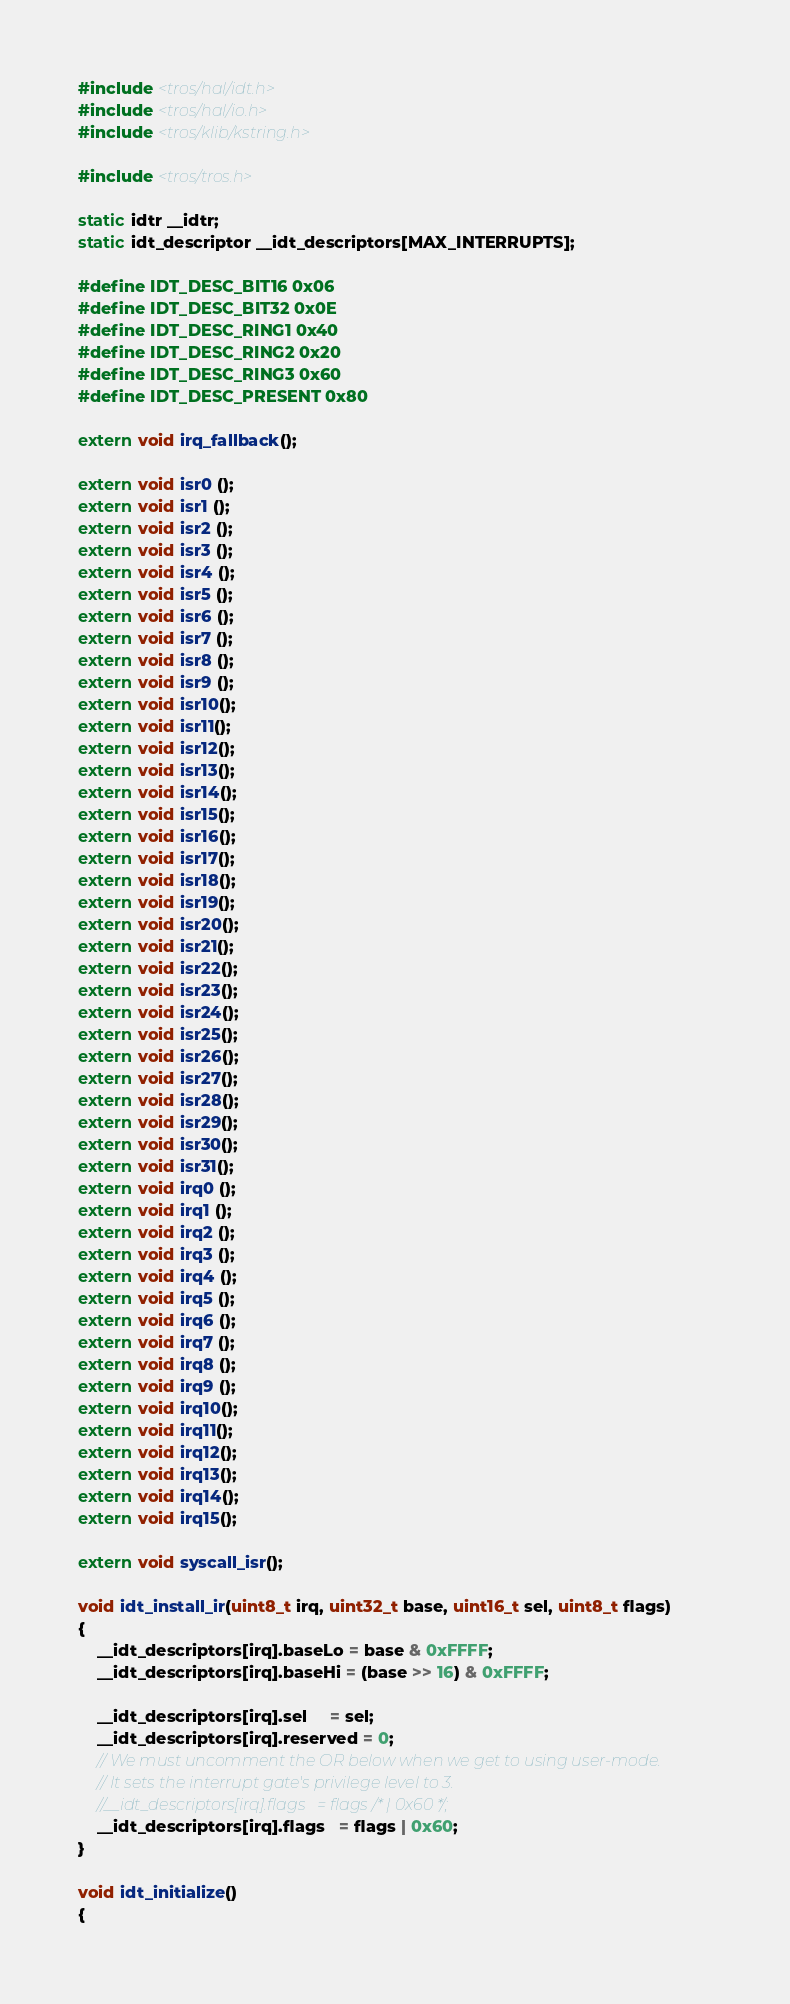<code> <loc_0><loc_0><loc_500><loc_500><_C_>#include <tros/hal/idt.h>
#include <tros/hal/io.h>
#include <tros/klib/kstring.h>

#include <tros/tros.h>

static idtr __idtr;
static idt_descriptor __idt_descriptors[MAX_INTERRUPTS];

#define IDT_DESC_BIT16 0x06
#define IDT_DESC_BIT32 0x0E
#define IDT_DESC_RING1 0x40
#define IDT_DESC_RING2 0x20
#define IDT_DESC_RING3 0x60
#define IDT_DESC_PRESENT 0x80

extern void irq_fallback();

extern void isr0 ();
extern void isr1 ();
extern void isr2 ();
extern void isr3 ();
extern void isr4 ();
extern void isr5 ();
extern void isr6 ();
extern void isr7 ();
extern void isr8 ();
extern void isr9 ();
extern void isr10();
extern void isr11();
extern void isr12();
extern void isr13();
extern void isr14();
extern void isr15();
extern void isr16();
extern void isr17();
extern void isr18();
extern void isr19();
extern void isr20();
extern void isr21();
extern void isr22();
extern void isr23();
extern void isr24();
extern void isr25();
extern void isr26();
extern void isr27();
extern void isr28();
extern void isr29();
extern void isr30();
extern void isr31();
extern void irq0 ();
extern void irq1 ();
extern void irq2 ();
extern void irq3 ();
extern void irq4 ();
extern void irq5 ();
extern void irq6 ();
extern void irq7 ();
extern void irq8 ();
extern void irq9 ();
extern void irq10();
extern void irq11();
extern void irq12();
extern void irq13();
extern void irq14();
extern void irq15();

extern void syscall_isr();

void idt_install_ir(uint8_t irq, uint32_t base, uint16_t sel, uint8_t flags)
{
    __idt_descriptors[irq].baseLo = base & 0xFFFF;
    __idt_descriptors[irq].baseHi = (base >> 16) & 0xFFFF;

    __idt_descriptors[irq].sel     = sel;
    __idt_descriptors[irq].reserved = 0;
    // We must uncomment the OR below when we get to using user-mode.
    // It sets the interrupt gate's privilege level to 3.
    //__idt_descriptors[irq].flags   = flags /* | 0x60 */;
    __idt_descriptors[irq].flags   = flags | 0x60;
}

void idt_initialize()
{</code> 